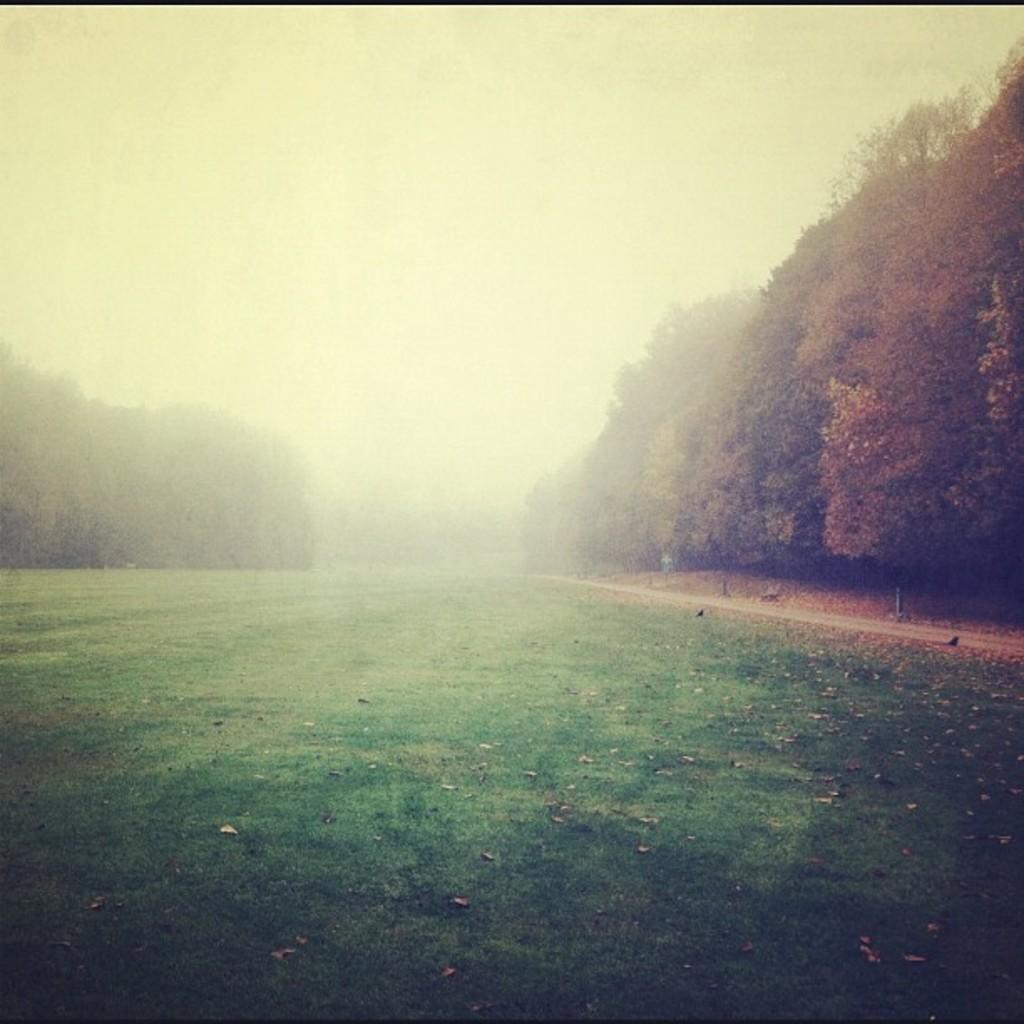Can you describe this image briefly? In this image we can see the ground covered with grass, there are some trees and in the background we can see the sky. 